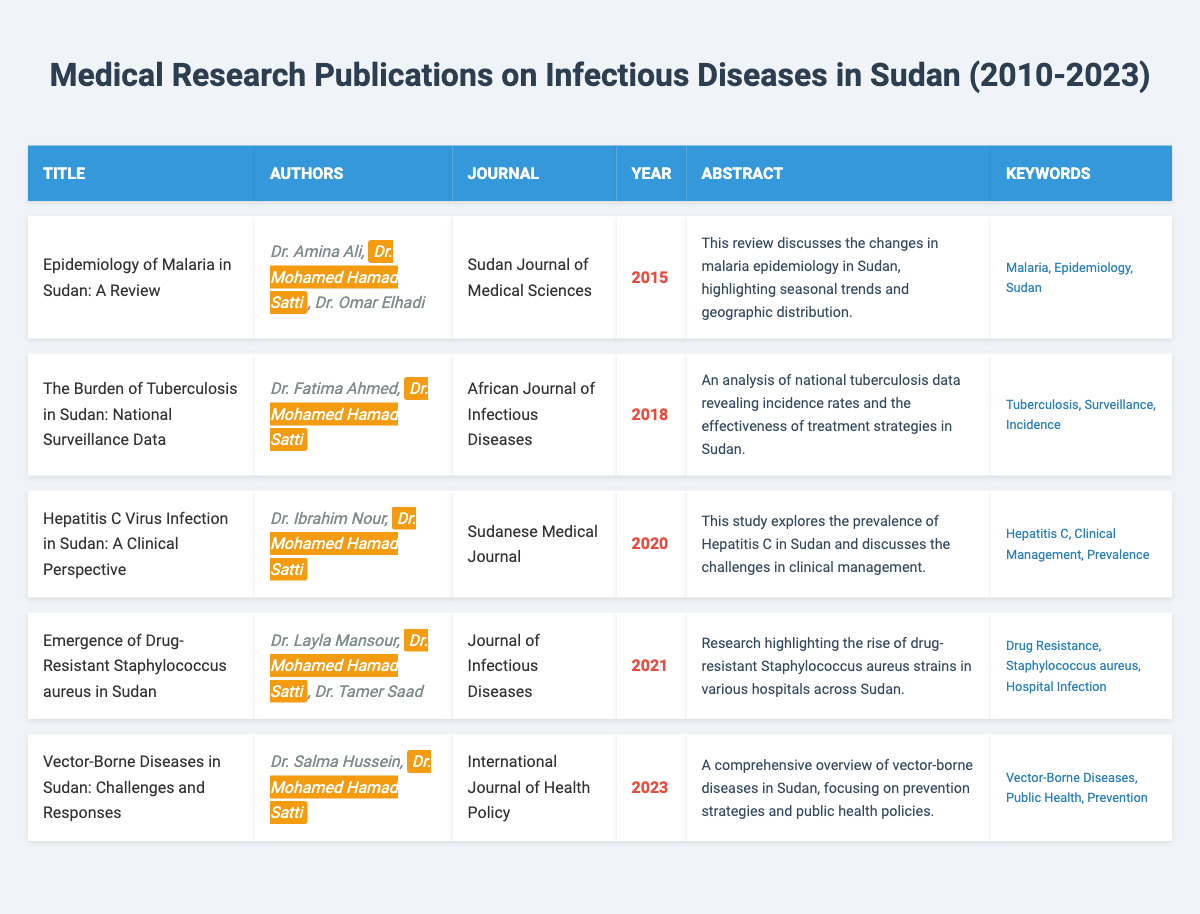What is the title of the publication where Dr. Mohamed Hamad Satti is the only author? To find the title, I look through the table for entries where Dr. Mohamed Hamad Satti is listed as an author. In this case, there are no entries where he is the only author; all publications have co-authors.
Answer: None Which journal published the article on drug-resistant Staphylococcus aureus? The table has a column for journals, and I can find the row related to drug-resistant Staphylococcus aureus. The corresponding journal is the "Journal of Infectious Diseases."
Answer: Journal of Infectious Diseases How many publications were authored or co-authored by Dr. Mohamed Hamad Satti? I will count the total number of publications listed in the table where Dr. Mohamed Hamad Satti appears as an author or co-author. There are five publications in which he is involved.
Answer: 5 In which year was the publication about Hepatitis C Virus infection released? I refer to the table and search for the row containing the publication on Hepatitis C Virus infection. This entry shows that it was published in 2020.
Answer: 2020 True or False: The publication titled "Vector-Borne Diseases in Sudan: Challenges and Responses" includes Dr. Salma Hussein as an author. I check the authors listed for the publication "Vector-Borne Diseases in Sudan: Challenges and Responses" and see that Dr. Salma Hussein is indeed listed as one of the authors.
Answer: True What are the keywords associated with the article about tuberculosis? I will look at the entry for the publication related to tuberculosis in the table and read the keywords provided, which are "Tuberculosis, Surveillance, Incidence."
Answer: Tuberculosis, Surveillance, Incidence Calculate the number of publications focusing on malaria and tuberculosis combined. I check the titles of the publications for those related to malaria and tuberculosis. The article on malaria is "Epidemiology of Malaria in Sudan: A Review" and the tuberculosis article is "The Burden of Tuberculosis in Sudan: National Surveillance Data." Therefore, the total is 2 publications.
Answer: 2 Which publication has the latest publication year, and what is its title? I check the years in the rightmost column of the table, identifying the maximum year listed, which is 2023. The publication from that year is titled "Vector-Borne Diseases in Sudan: Challenges and Responses."
Answer: Vector-Borne Diseases in Sudan: Challenges and Responses How many different journals were involved in publishing Dr. Mohamed Hamad Satti's research? I will review the journal names for each of Dr. Mohamed Hamad Satti's publications, identifying distinct journals. The journals are: "Sudan Journal of Medical Sciences," "African Journal of Infectious Diseases," "Sudanese Medical Journal," "Journal of Infectious Diseases," and "International Journal of Health Policy," totaling five different journals.
Answer: 5 Identify the author who collaborated with Dr. Mohamed Hamad Satti on the publication about drug-resistant Staphylococcus aureus. Looking at the authors listed for the publication concerning drug-resistant Staphylococcus aureus, I see that Dr. Layla Mansour and Dr. Tamer Saad are co-authors with Dr. Satti.
Answer: Dr. Layla Mansour and Dr. Tamer Saad 